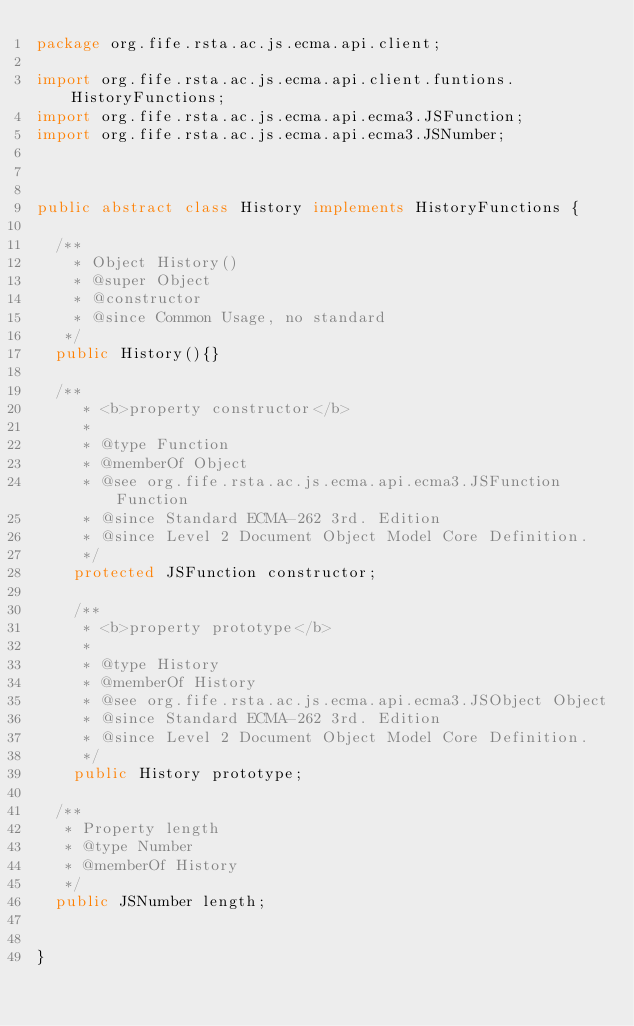<code> <loc_0><loc_0><loc_500><loc_500><_Java_>package org.fife.rsta.ac.js.ecma.api.client;

import org.fife.rsta.ac.js.ecma.api.client.funtions.HistoryFunctions;
import org.fife.rsta.ac.js.ecma.api.ecma3.JSFunction;
import org.fife.rsta.ac.js.ecma.api.ecma3.JSNumber;



public abstract class History implements HistoryFunctions {

	/**
	  * Object History()
	  * @super Object
	  * @constructor
	  * @since Common Usage, no standard
	 */
	public History(){}

	/**
     * <b>property constructor</b>
     * 
     * @type Function
     * @memberOf Object
     * @see org.fife.rsta.ac.js.ecma.api.ecma3.JSFunction Function
     * @since Standard ECMA-262 3rd. Edition
     * @since Level 2 Document Object Model Core Definition.
     */
    protected JSFunction constructor;
    
    /**
     * <b>property prototype</b>
     * 
     * @type History
     * @memberOf History
     * @see org.fife.rsta.ac.js.ecma.api.ecma3.JSObject Object
     * @since Standard ECMA-262 3rd. Edition
     * @since Level 2 Document Object Model Core Definition.
     */
    public History prototype;
	
	/**
	 * Property length
	 * @type Number
	 * @memberOf History
	 */
	public JSNumber length;
	
	
}
</code> 